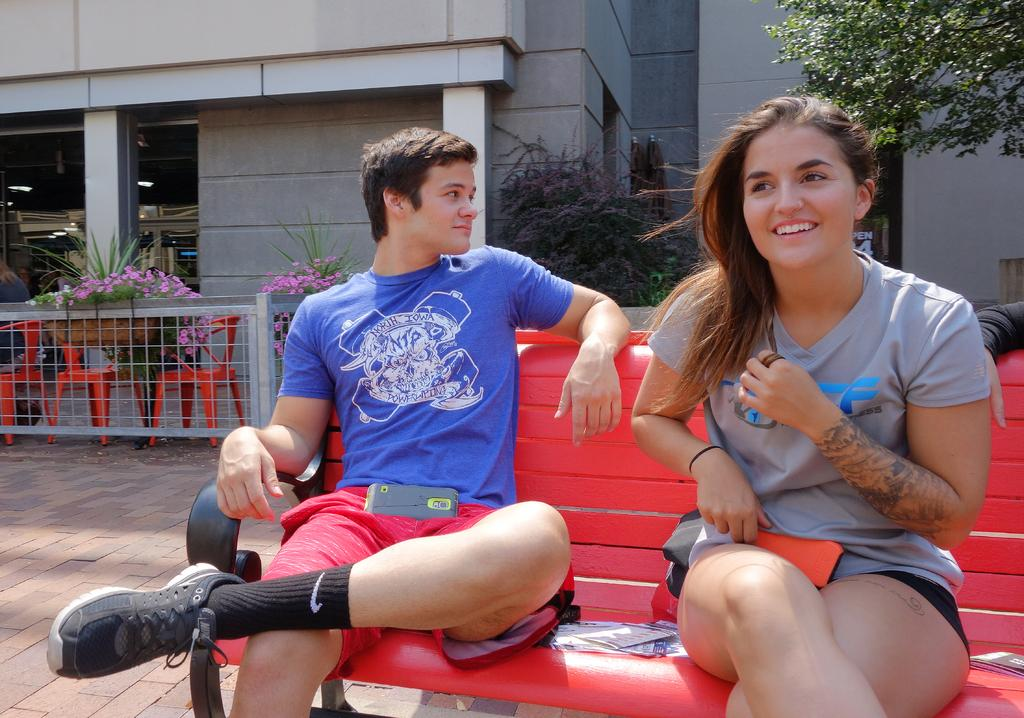How many people are present in the image? There are two people in the image, a girl and a boy. What are the girl and the boy doing in the image? The girl and the boy are sitting on a bench. What can be seen in the background of the image? There are flower plants, chairs, a boundary, a building structure, and a tree in the background of the image. How many chickens are present in the image? There are no chickens present in the image. What type of test is being conducted in the image? There is no test being conducted in the image. 